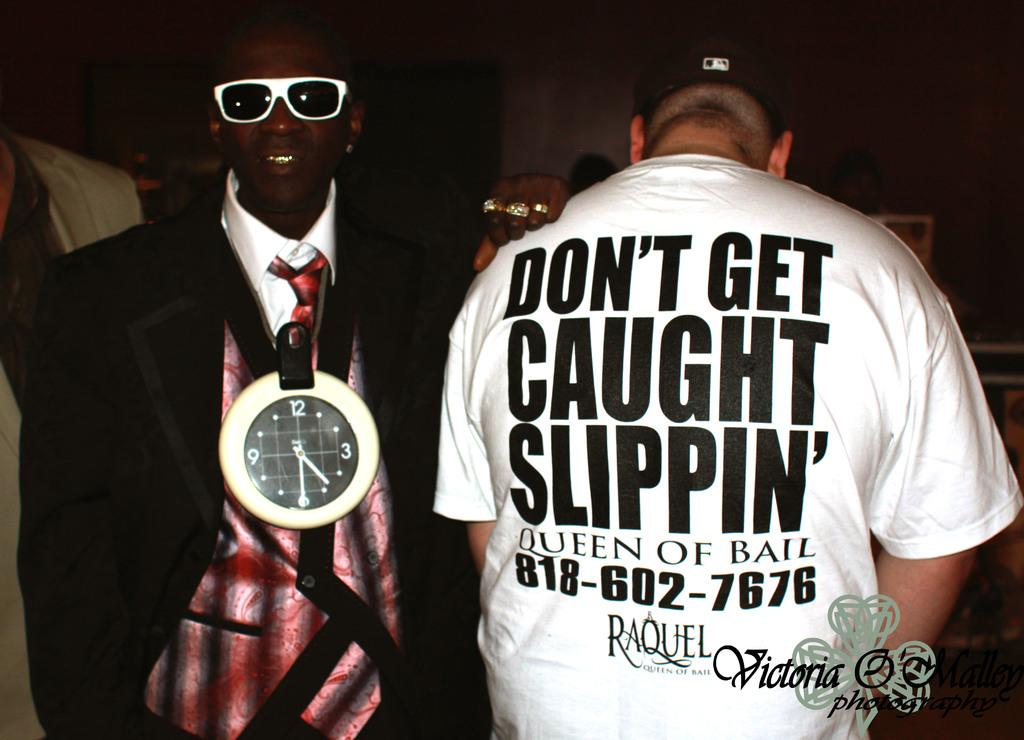<image>
Offer a succinct explanation of the picture presented. A man wearing a shirt with the word caught on it. 